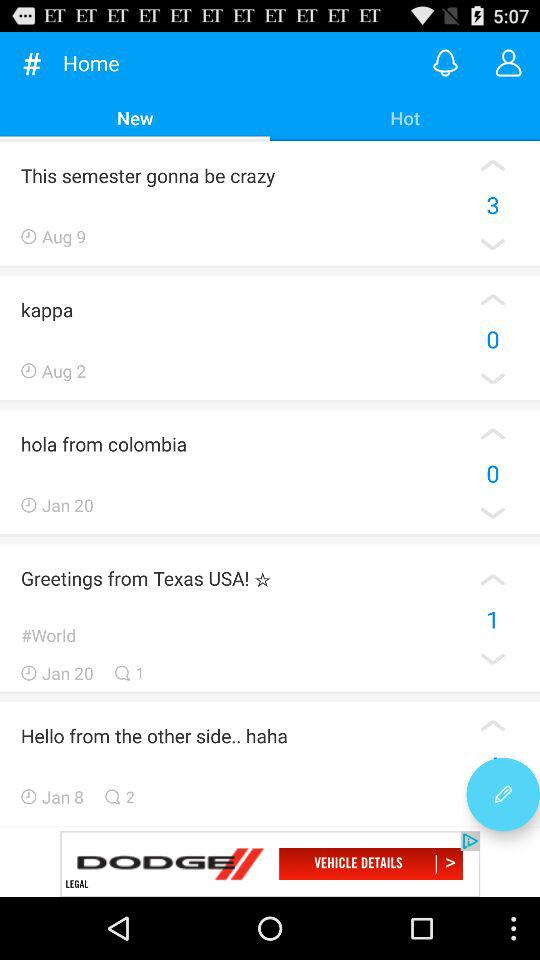How many comments are there on "Hello from the other side"? There are two comments on "Hello from the other side". 